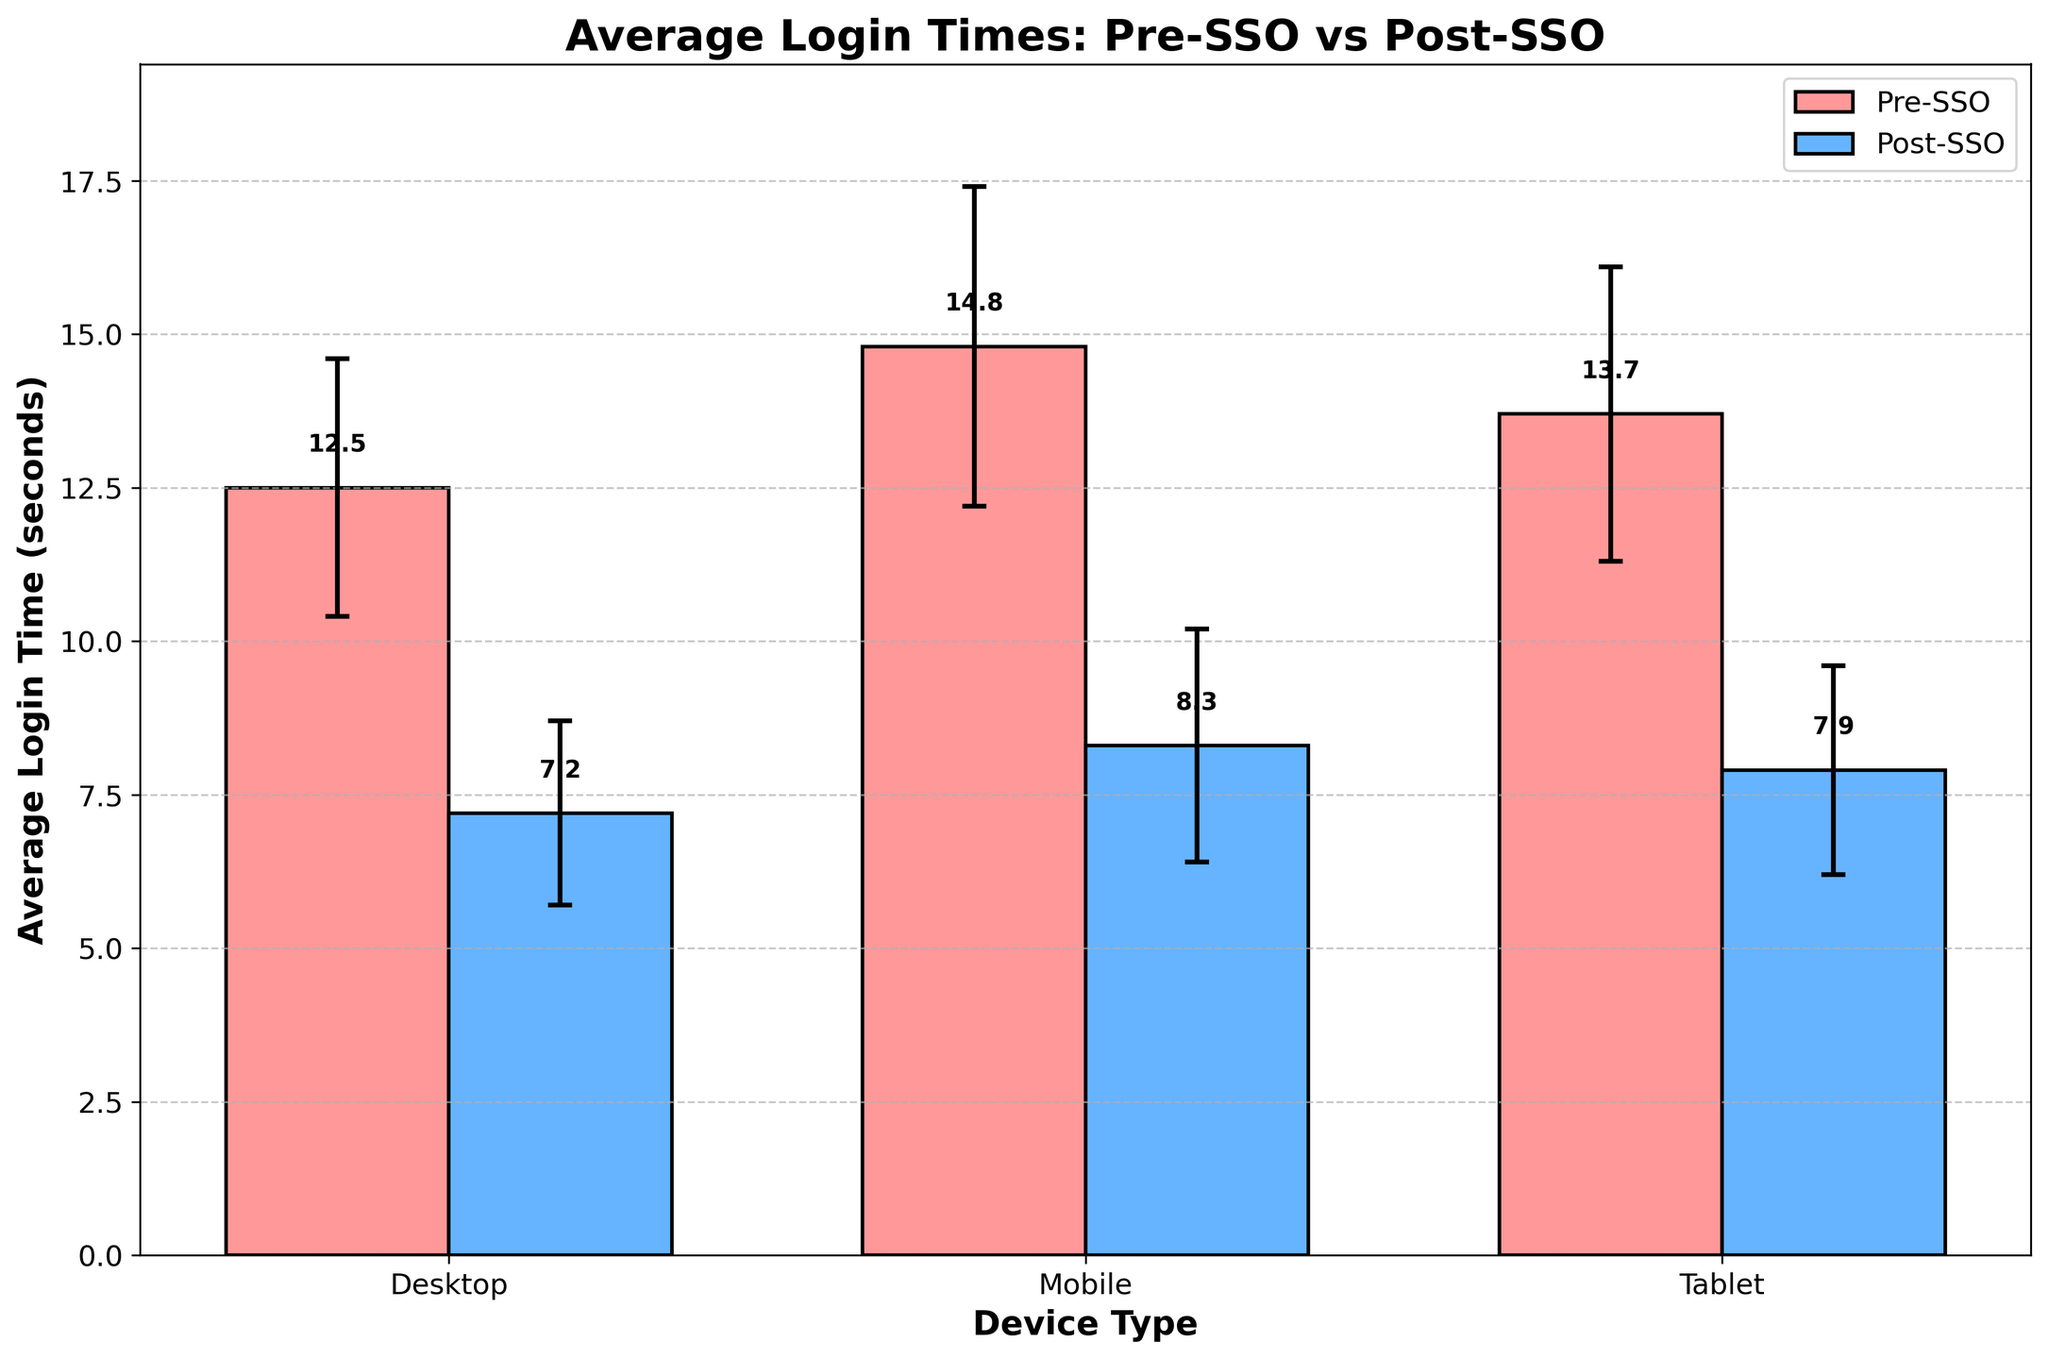What's the title of the plot? The title of the plot is shown at the top of the figure in bold font. It reads "Average Login Times: Pre-SSO vs Post-SSO".
Answer: Average Login Times: Pre-SSO vs Post-SSO What are the labels of the x-axis and y-axis? The labels of the x-axis and y-axis are displayed in bold font along the respective axes. The x-axis is labeled "Device Type" and the y-axis is labeled "Average Login Time (seconds)".
Answer: x-axis: Device Type, y-axis: Average Login Time (seconds) Which device type shows the greatest reduction in average login time from Pre-SSO to Post-SSO? To find the device with the greatest reduction, look at the heights of the bars for each device type pre- and post-SSO and calculate the difference. The desktop shows the greatest reduction (12.5s to 7.2s) with a difference of 5.3s.
Answer: Desktop What is the average login time for mobile devices after SSO implementation? The average login time for each condition is displayed at the top of each bar. For mobile devices post-SSO, the bar shows an average login time of 8.3 seconds.
Answer: 8.3 seconds Which condition has the higher average login time for tablets? Compare the heights of the bars for tablets under both conditions. The Pre-SSO condition shows a higher average login time (13.7 seconds) compared to the Post-SSO (7.9 seconds).
Answer: Pre-SSO What is the standard deviation of the average login time for desktop devices pre-SSO? The standard deviation of the average login time can be identified by the error bars extending above and below the bars. For desktop devices pre-SSO, the error bar has a standard deviation of 2.1 seconds.
Answer: 2.1 seconds By how much did the average login time reduce for tablets after implementing SSO? Subtract the average login time post-SSO from the average login time pre-SSO for tablets (13.7s - 7.9s).
Answer: 5.8 seconds Which device type shows the smallest standard deviation in the post-SSO condition? Compare the lengths of the error bars for each device type in the post-SSO condition. Tablet devices have the smallest standard deviation with an error bar length of 1.7 seconds.
Answer: Tablet What is the difference between mobile and desktop average login times in the pre-SSO condition? Subtract the average login time for desktop from the mobile in the pre-SSO condition (14.8s - 12.5s).
Answer: 2.3 seconds 